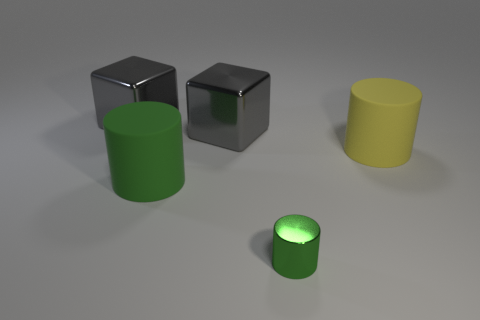Add 3 small cylinders. How many objects exist? 8 Subtract all cylinders. How many objects are left? 2 Subtract all tiny green things. Subtract all cylinders. How many objects are left? 1 Add 3 green objects. How many green objects are left? 5 Add 3 big metallic blocks. How many big metallic blocks exist? 5 Subtract 2 green cylinders. How many objects are left? 3 